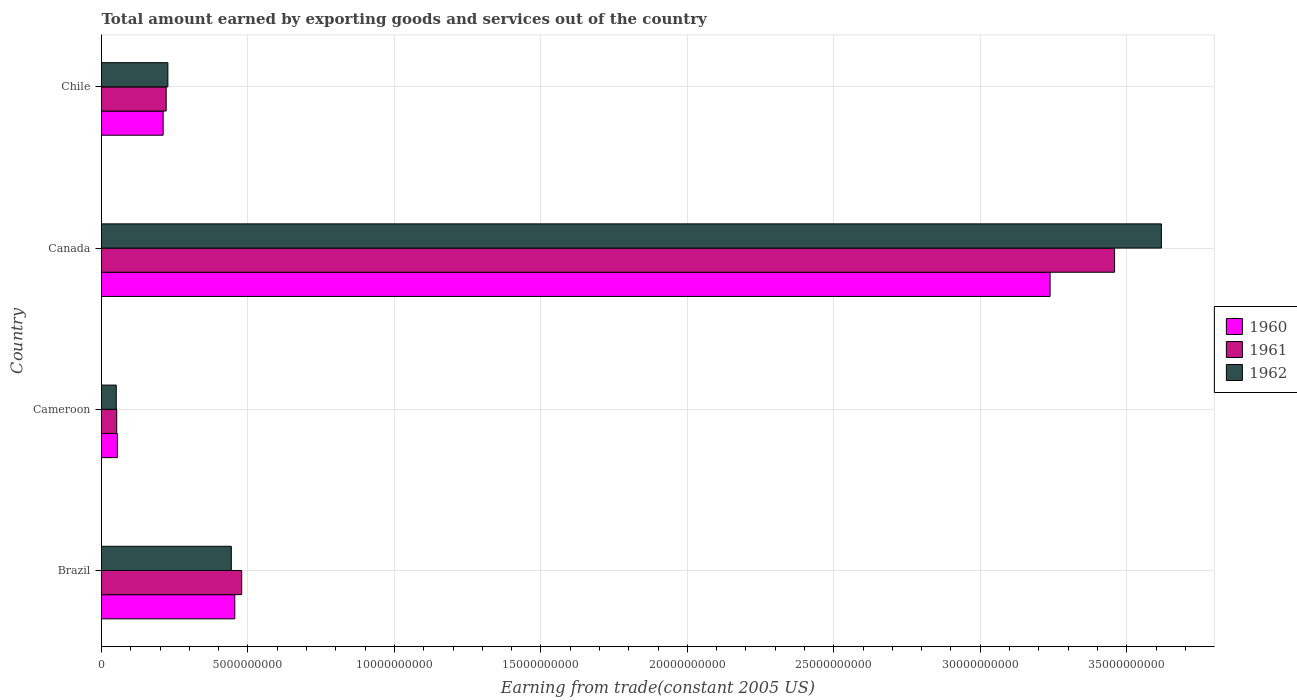How many different coloured bars are there?
Offer a very short reply. 3. How many groups of bars are there?
Give a very brief answer. 4. Are the number of bars per tick equal to the number of legend labels?
Offer a very short reply. Yes. Are the number of bars on each tick of the Y-axis equal?
Make the answer very short. Yes. How many bars are there on the 3rd tick from the top?
Your answer should be very brief. 3. What is the label of the 4th group of bars from the top?
Offer a very short reply. Brazil. What is the total amount earned by exporting goods and services in 1961 in Chile?
Make the answer very short. 2.21e+09. Across all countries, what is the maximum total amount earned by exporting goods and services in 1961?
Provide a succinct answer. 3.46e+1. Across all countries, what is the minimum total amount earned by exporting goods and services in 1962?
Your response must be concise. 5.04e+08. In which country was the total amount earned by exporting goods and services in 1962 maximum?
Give a very brief answer. Canada. In which country was the total amount earned by exporting goods and services in 1962 minimum?
Provide a short and direct response. Cameroon. What is the total total amount earned by exporting goods and services in 1962 in the graph?
Give a very brief answer. 4.34e+1. What is the difference between the total amount earned by exporting goods and services in 1961 in Brazil and that in Canada?
Give a very brief answer. -2.98e+1. What is the difference between the total amount earned by exporting goods and services in 1961 in Canada and the total amount earned by exporting goods and services in 1960 in Brazil?
Make the answer very short. 3.00e+1. What is the average total amount earned by exporting goods and services in 1962 per country?
Give a very brief answer. 1.08e+1. What is the difference between the total amount earned by exporting goods and services in 1961 and total amount earned by exporting goods and services in 1960 in Brazil?
Your answer should be compact. 2.36e+08. What is the ratio of the total amount earned by exporting goods and services in 1961 in Brazil to that in Canada?
Keep it short and to the point. 0.14. Is the total amount earned by exporting goods and services in 1961 in Canada less than that in Chile?
Keep it short and to the point. No. What is the difference between the highest and the second highest total amount earned by exporting goods and services in 1960?
Your answer should be very brief. 2.78e+1. What is the difference between the highest and the lowest total amount earned by exporting goods and services in 1961?
Your answer should be compact. 3.41e+1. Is the sum of the total amount earned by exporting goods and services in 1960 in Canada and Chile greater than the maximum total amount earned by exporting goods and services in 1962 across all countries?
Your answer should be very brief. No. How many bars are there?
Offer a very short reply. 12. Are all the bars in the graph horizontal?
Your response must be concise. Yes. Does the graph contain grids?
Provide a short and direct response. Yes. How many legend labels are there?
Offer a very short reply. 3. What is the title of the graph?
Provide a succinct answer. Total amount earned by exporting goods and services out of the country. What is the label or title of the X-axis?
Make the answer very short. Earning from trade(constant 2005 US). What is the label or title of the Y-axis?
Ensure brevity in your answer.  Country. What is the Earning from trade(constant 2005 US) of 1960 in Brazil?
Ensure brevity in your answer.  4.55e+09. What is the Earning from trade(constant 2005 US) of 1961 in Brazil?
Offer a very short reply. 4.79e+09. What is the Earning from trade(constant 2005 US) in 1962 in Brazil?
Give a very brief answer. 4.43e+09. What is the Earning from trade(constant 2005 US) of 1960 in Cameroon?
Offer a very short reply. 5.42e+08. What is the Earning from trade(constant 2005 US) in 1961 in Cameroon?
Give a very brief answer. 5.19e+08. What is the Earning from trade(constant 2005 US) of 1962 in Cameroon?
Give a very brief answer. 5.04e+08. What is the Earning from trade(constant 2005 US) of 1960 in Canada?
Your answer should be compact. 3.24e+1. What is the Earning from trade(constant 2005 US) in 1961 in Canada?
Your response must be concise. 3.46e+1. What is the Earning from trade(constant 2005 US) of 1962 in Canada?
Ensure brevity in your answer.  3.62e+1. What is the Earning from trade(constant 2005 US) in 1960 in Chile?
Offer a terse response. 2.10e+09. What is the Earning from trade(constant 2005 US) in 1961 in Chile?
Ensure brevity in your answer.  2.21e+09. What is the Earning from trade(constant 2005 US) of 1962 in Chile?
Your answer should be very brief. 2.27e+09. Across all countries, what is the maximum Earning from trade(constant 2005 US) of 1960?
Give a very brief answer. 3.24e+1. Across all countries, what is the maximum Earning from trade(constant 2005 US) in 1961?
Offer a terse response. 3.46e+1. Across all countries, what is the maximum Earning from trade(constant 2005 US) of 1962?
Keep it short and to the point. 3.62e+1. Across all countries, what is the minimum Earning from trade(constant 2005 US) in 1960?
Your answer should be compact. 5.42e+08. Across all countries, what is the minimum Earning from trade(constant 2005 US) in 1961?
Ensure brevity in your answer.  5.19e+08. Across all countries, what is the minimum Earning from trade(constant 2005 US) of 1962?
Your answer should be compact. 5.04e+08. What is the total Earning from trade(constant 2005 US) of 1960 in the graph?
Offer a terse response. 3.96e+1. What is the total Earning from trade(constant 2005 US) of 1961 in the graph?
Provide a short and direct response. 4.21e+1. What is the total Earning from trade(constant 2005 US) of 1962 in the graph?
Offer a terse response. 4.34e+1. What is the difference between the Earning from trade(constant 2005 US) in 1960 in Brazil and that in Cameroon?
Keep it short and to the point. 4.01e+09. What is the difference between the Earning from trade(constant 2005 US) in 1961 in Brazil and that in Cameroon?
Provide a short and direct response. 4.27e+09. What is the difference between the Earning from trade(constant 2005 US) of 1962 in Brazil and that in Cameroon?
Give a very brief answer. 3.93e+09. What is the difference between the Earning from trade(constant 2005 US) in 1960 in Brazil and that in Canada?
Keep it short and to the point. -2.78e+1. What is the difference between the Earning from trade(constant 2005 US) in 1961 in Brazil and that in Canada?
Ensure brevity in your answer.  -2.98e+1. What is the difference between the Earning from trade(constant 2005 US) of 1962 in Brazil and that in Canada?
Give a very brief answer. -3.18e+1. What is the difference between the Earning from trade(constant 2005 US) in 1960 in Brazil and that in Chile?
Your answer should be very brief. 2.45e+09. What is the difference between the Earning from trade(constant 2005 US) of 1961 in Brazil and that in Chile?
Provide a succinct answer. 2.58e+09. What is the difference between the Earning from trade(constant 2005 US) of 1962 in Brazil and that in Chile?
Provide a succinct answer. 2.17e+09. What is the difference between the Earning from trade(constant 2005 US) in 1960 in Cameroon and that in Canada?
Provide a short and direct response. -3.18e+1. What is the difference between the Earning from trade(constant 2005 US) in 1961 in Cameroon and that in Canada?
Your response must be concise. -3.41e+1. What is the difference between the Earning from trade(constant 2005 US) in 1962 in Cameroon and that in Canada?
Your response must be concise. -3.57e+1. What is the difference between the Earning from trade(constant 2005 US) in 1960 in Cameroon and that in Chile?
Make the answer very short. -1.56e+09. What is the difference between the Earning from trade(constant 2005 US) of 1961 in Cameroon and that in Chile?
Give a very brief answer. -1.69e+09. What is the difference between the Earning from trade(constant 2005 US) of 1962 in Cameroon and that in Chile?
Your response must be concise. -1.76e+09. What is the difference between the Earning from trade(constant 2005 US) in 1960 in Canada and that in Chile?
Keep it short and to the point. 3.03e+1. What is the difference between the Earning from trade(constant 2005 US) in 1961 in Canada and that in Chile?
Your answer should be very brief. 3.24e+1. What is the difference between the Earning from trade(constant 2005 US) of 1962 in Canada and that in Chile?
Offer a very short reply. 3.39e+1. What is the difference between the Earning from trade(constant 2005 US) of 1960 in Brazil and the Earning from trade(constant 2005 US) of 1961 in Cameroon?
Your answer should be compact. 4.03e+09. What is the difference between the Earning from trade(constant 2005 US) in 1960 in Brazil and the Earning from trade(constant 2005 US) in 1962 in Cameroon?
Your answer should be compact. 4.05e+09. What is the difference between the Earning from trade(constant 2005 US) in 1961 in Brazil and the Earning from trade(constant 2005 US) in 1962 in Cameroon?
Your answer should be very brief. 4.28e+09. What is the difference between the Earning from trade(constant 2005 US) of 1960 in Brazil and the Earning from trade(constant 2005 US) of 1961 in Canada?
Provide a short and direct response. -3.00e+1. What is the difference between the Earning from trade(constant 2005 US) of 1960 in Brazil and the Earning from trade(constant 2005 US) of 1962 in Canada?
Your answer should be compact. -3.16e+1. What is the difference between the Earning from trade(constant 2005 US) of 1961 in Brazil and the Earning from trade(constant 2005 US) of 1962 in Canada?
Offer a terse response. -3.14e+1. What is the difference between the Earning from trade(constant 2005 US) of 1960 in Brazil and the Earning from trade(constant 2005 US) of 1961 in Chile?
Ensure brevity in your answer.  2.34e+09. What is the difference between the Earning from trade(constant 2005 US) in 1960 in Brazil and the Earning from trade(constant 2005 US) in 1962 in Chile?
Offer a terse response. 2.28e+09. What is the difference between the Earning from trade(constant 2005 US) in 1961 in Brazil and the Earning from trade(constant 2005 US) in 1962 in Chile?
Keep it short and to the point. 2.52e+09. What is the difference between the Earning from trade(constant 2005 US) in 1960 in Cameroon and the Earning from trade(constant 2005 US) in 1961 in Canada?
Your answer should be compact. -3.40e+1. What is the difference between the Earning from trade(constant 2005 US) of 1960 in Cameroon and the Earning from trade(constant 2005 US) of 1962 in Canada?
Offer a very short reply. -3.56e+1. What is the difference between the Earning from trade(constant 2005 US) of 1961 in Cameroon and the Earning from trade(constant 2005 US) of 1962 in Canada?
Offer a very short reply. -3.57e+1. What is the difference between the Earning from trade(constant 2005 US) in 1960 in Cameroon and the Earning from trade(constant 2005 US) in 1961 in Chile?
Your answer should be compact. -1.67e+09. What is the difference between the Earning from trade(constant 2005 US) of 1960 in Cameroon and the Earning from trade(constant 2005 US) of 1962 in Chile?
Give a very brief answer. -1.72e+09. What is the difference between the Earning from trade(constant 2005 US) of 1961 in Cameroon and the Earning from trade(constant 2005 US) of 1962 in Chile?
Your answer should be compact. -1.75e+09. What is the difference between the Earning from trade(constant 2005 US) of 1960 in Canada and the Earning from trade(constant 2005 US) of 1961 in Chile?
Provide a short and direct response. 3.02e+1. What is the difference between the Earning from trade(constant 2005 US) of 1960 in Canada and the Earning from trade(constant 2005 US) of 1962 in Chile?
Offer a terse response. 3.01e+1. What is the difference between the Earning from trade(constant 2005 US) in 1961 in Canada and the Earning from trade(constant 2005 US) in 1962 in Chile?
Ensure brevity in your answer.  3.23e+1. What is the average Earning from trade(constant 2005 US) of 1960 per country?
Your answer should be very brief. 9.90e+09. What is the average Earning from trade(constant 2005 US) in 1961 per country?
Keep it short and to the point. 1.05e+1. What is the average Earning from trade(constant 2005 US) of 1962 per country?
Your answer should be very brief. 1.08e+1. What is the difference between the Earning from trade(constant 2005 US) of 1960 and Earning from trade(constant 2005 US) of 1961 in Brazil?
Ensure brevity in your answer.  -2.36e+08. What is the difference between the Earning from trade(constant 2005 US) of 1960 and Earning from trade(constant 2005 US) of 1962 in Brazil?
Keep it short and to the point. 1.18e+08. What is the difference between the Earning from trade(constant 2005 US) of 1961 and Earning from trade(constant 2005 US) of 1962 in Brazil?
Provide a short and direct response. 3.55e+08. What is the difference between the Earning from trade(constant 2005 US) in 1960 and Earning from trade(constant 2005 US) in 1961 in Cameroon?
Provide a short and direct response. 2.31e+07. What is the difference between the Earning from trade(constant 2005 US) of 1960 and Earning from trade(constant 2005 US) of 1962 in Cameroon?
Your response must be concise. 3.82e+07. What is the difference between the Earning from trade(constant 2005 US) in 1961 and Earning from trade(constant 2005 US) in 1962 in Cameroon?
Your response must be concise. 1.51e+07. What is the difference between the Earning from trade(constant 2005 US) in 1960 and Earning from trade(constant 2005 US) in 1961 in Canada?
Offer a very short reply. -2.20e+09. What is the difference between the Earning from trade(constant 2005 US) in 1960 and Earning from trade(constant 2005 US) in 1962 in Canada?
Ensure brevity in your answer.  -3.80e+09. What is the difference between the Earning from trade(constant 2005 US) in 1961 and Earning from trade(constant 2005 US) in 1962 in Canada?
Your response must be concise. -1.60e+09. What is the difference between the Earning from trade(constant 2005 US) in 1960 and Earning from trade(constant 2005 US) in 1961 in Chile?
Offer a very short reply. -1.04e+08. What is the difference between the Earning from trade(constant 2005 US) of 1960 and Earning from trade(constant 2005 US) of 1962 in Chile?
Keep it short and to the point. -1.62e+08. What is the difference between the Earning from trade(constant 2005 US) in 1961 and Earning from trade(constant 2005 US) in 1962 in Chile?
Your answer should be very brief. -5.76e+07. What is the ratio of the Earning from trade(constant 2005 US) of 1960 in Brazil to that in Cameroon?
Keep it short and to the point. 8.39. What is the ratio of the Earning from trade(constant 2005 US) of 1961 in Brazil to that in Cameroon?
Provide a succinct answer. 9.22. What is the ratio of the Earning from trade(constant 2005 US) of 1962 in Brazil to that in Cameroon?
Give a very brief answer. 8.79. What is the ratio of the Earning from trade(constant 2005 US) in 1960 in Brazil to that in Canada?
Your answer should be very brief. 0.14. What is the ratio of the Earning from trade(constant 2005 US) in 1961 in Brazil to that in Canada?
Offer a terse response. 0.14. What is the ratio of the Earning from trade(constant 2005 US) of 1962 in Brazil to that in Canada?
Your answer should be compact. 0.12. What is the ratio of the Earning from trade(constant 2005 US) in 1960 in Brazil to that in Chile?
Offer a very short reply. 2.16. What is the ratio of the Earning from trade(constant 2005 US) of 1961 in Brazil to that in Chile?
Provide a succinct answer. 2.17. What is the ratio of the Earning from trade(constant 2005 US) in 1962 in Brazil to that in Chile?
Offer a very short reply. 1.96. What is the ratio of the Earning from trade(constant 2005 US) of 1960 in Cameroon to that in Canada?
Your response must be concise. 0.02. What is the ratio of the Earning from trade(constant 2005 US) of 1961 in Cameroon to that in Canada?
Ensure brevity in your answer.  0.01. What is the ratio of the Earning from trade(constant 2005 US) in 1962 in Cameroon to that in Canada?
Ensure brevity in your answer.  0.01. What is the ratio of the Earning from trade(constant 2005 US) in 1960 in Cameroon to that in Chile?
Your answer should be very brief. 0.26. What is the ratio of the Earning from trade(constant 2005 US) in 1961 in Cameroon to that in Chile?
Make the answer very short. 0.24. What is the ratio of the Earning from trade(constant 2005 US) in 1962 in Cameroon to that in Chile?
Your answer should be very brief. 0.22. What is the ratio of the Earning from trade(constant 2005 US) in 1960 in Canada to that in Chile?
Provide a succinct answer. 15.39. What is the ratio of the Earning from trade(constant 2005 US) of 1961 in Canada to that in Chile?
Offer a terse response. 15.66. What is the ratio of the Earning from trade(constant 2005 US) of 1962 in Canada to that in Chile?
Offer a very short reply. 15.97. What is the difference between the highest and the second highest Earning from trade(constant 2005 US) of 1960?
Make the answer very short. 2.78e+1. What is the difference between the highest and the second highest Earning from trade(constant 2005 US) of 1961?
Provide a succinct answer. 2.98e+1. What is the difference between the highest and the second highest Earning from trade(constant 2005 US) in 1962?
Provide a short and direct response. 3.18e+1. What is the difference between the highest and the lowest Earning from trade(constant 2005 US) in 1960?
Ensure brevity in your answer.  3.18e+1. What is the difference between the highest and the lowest Earning from trade(constant 2005 US) in 1961?
Provide a short and direct response. 3.41e+1. What is the difference between the highest and the lowest Earning from trade(constant 2005 US) of 1962?
Your response must be concise. 3.57e+1. 